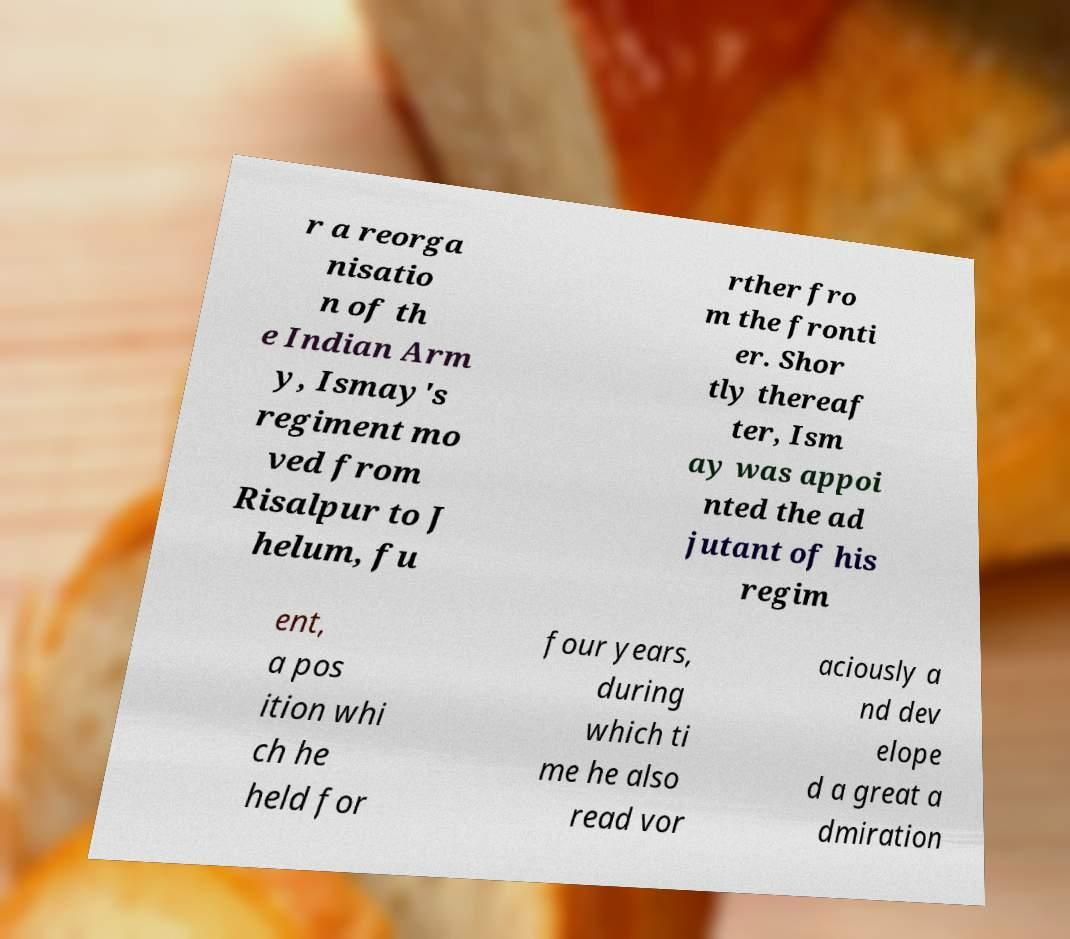Please read and relay the text visible in this image. What does it say? r a reorga nisatio n of th e Indian Arm y, Ismay's regiment mo ved from Risalpur to J helum, fu rther fro m the fronti er. Shor tly thereaf ter, Ism ay was appoi nted the ad jutant of his regim ent, a pos ition whi ch he held for four years, during which ti me he also read vor aciously a nd dev elope d a great a dmiration 